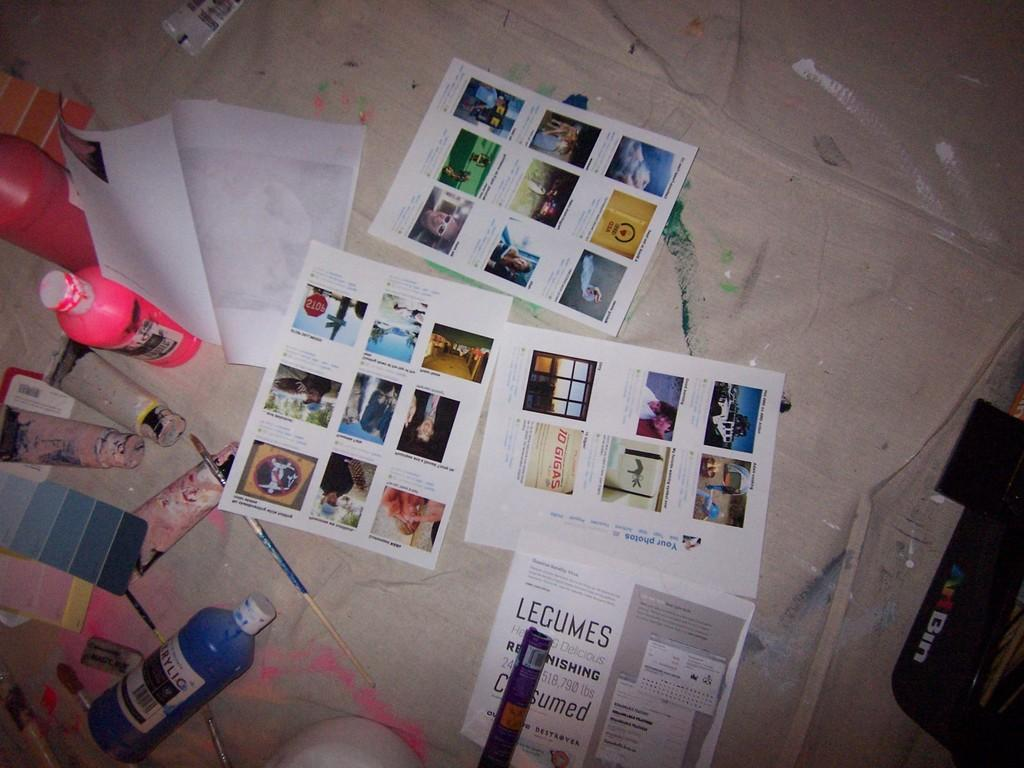<image>
Create a compact narrative representing the image presented. pictures and paint of the floor along with a flyer with the word Legumes on it 